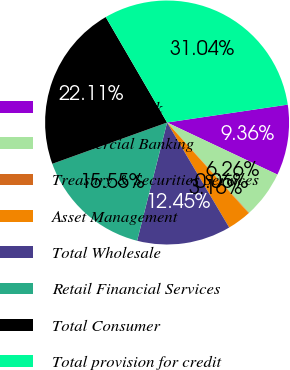Convert chart to OTSL. <chart><loc_0><loc_0><loc_500><loc_500><pie_chart><fcel>Investment Bank<fcel>Commercial Banking<fcel>Treasury & Securities Services<fcel>Asset Management<fcel>Total Wholesale<fcel>Retail Financial Services<fcel>Total Consumer<fcel>Total provision for credit<nl><fcel>9.36%<fcel>6.26%<fcel>0.06%<fcel>3.16%<fcel>12.45%<fcel>15.55%<fcel>22.11%<fcel>31.04%<nl></chart> 